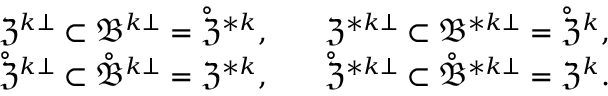Convert formula to latex. <formula><loc_0><loc_0><loc_500><loc_500>\begin{array} { r l r } & { \mathfrak { Z } ^ { k \bot } \subset \mathfrak { B } ^ { k \bot } = \mathring { \mathfrak { Z } } ^ { \ast k } , \quad } & { \mathfrak { Z } ^ { \ast k \bot } \subset \mathfrak { B } ^ { \ast k \bot } = \mathring { \mathfrak { Z } } ^ { k } , } \\ & { \mathring { \mathfrak { Z } } ^ { k \bot } \subset \mathring { \mathfrak { B } } ^ { k \bot } = \mathfrak { Z } ^ { \ast k } , \quad } & { \mathring { \mathfrak { Z } } ^ { \ast k \bot } \subset \mathring { \mathfrak { B } } ^ { \ast k \bot } = \mathfrak { Z } ^ { k } . } \end{array}</formula> 